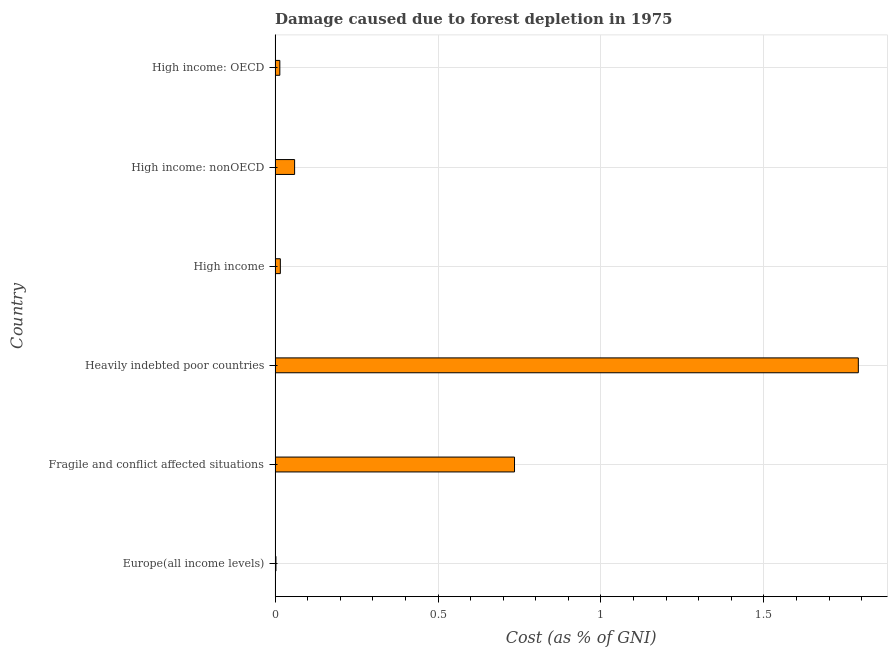Does the graph contain grids?
Provide a succinct answer. Yes. What is the title of the graph?
Offer a very short reply. Damage caused due to forest depletion in 1975. What is the label or title of the X-axis?
Provide a short and direct response. Cost (as % of GNI). What is the damage caused due to forest depletion in High income: nonOECD?
Your answer should be very brief. 0.06. Across all countries, what is the maximum damage caused due to forest depletion?
Keep it short and to the point. 1.79. Across all countries, what is the minimum damage caused due to forest depletion?
Your answer should be very brief. 0. In which country was the damage caused due to forest depletion maximum?
Provide a succinct answer. Heavily indebted poor countries. In which country was the damage caused due to forest depletion minimum?
Provide a short and direct response. Europe(all income levels). What is the sum of the damage caused due to forest depletion?
Give a very brief answer. 2.62. What is the difference between the damage caused due to forest depletion in Heavily indebted poor countries and High income: nonOECD?
Ensure brevity in your answer.  1.73. What is the average damage caused due to forest depletion per country?
Keep it short and to the point. 0.44. What is the median damage caused due to forest depletion?
Your answer should be very brief. 0.04. In how many countries, is the damage caused due to forest depletion greater than 1.1 %?
Provide a succinct answer. 1. What is the ratio of the damage caused due to forest depletion in High income: OECD to that in High income: nonOECD?
Your answer should be compact. 0.24. Is the difference between the damage caused due to forest depletion in Fragile and conflict affected situations and High income greater than the difference between any two countries?
Give a very brief answer. No. What is the difference between the highest and the second highest damage caused due to forest depletion?
Offer a terse response. 1.05. Is the sum of the damage caused due to forest depletion in Fragile and conflict affected situations and High income greater than the maximum damage caused due to forest depletion across all countries?
Your answer should be compact. No. What is the difference between the highest and the lowest damage caused due to forest depletion?
Make the answer very short. 1.79. How many bars are there?
Offer a very short reply. 6. What is the difference between two consecutive major ticks on the X-axis?
Offer a very short reply. 0.5. What is the Cost (as % of GNI) in Europe(all income levels)?
Keep it short and to the point. 0. What is the Cost (as % of GNI) in Fragile and conflict affected situations?
Provide a succinct answer. 0.73. What is the Cost (as % of GNI) of Heavily indebted poor countries?
Provide a succinct answer. 1.79. What is the Cost (as % of GNI) of High income?
Your answer should be very brief. 0.02. What is the Cost (as % of GNI) in High income: nonOECD?
Ensure brevity in your answer.  0.06. What is the Cost (as % of GNI) in High income: OECD?
Keep it short and to the point. 0.01. What is the difference between the Cost (as % of GNI) in Europe(all income levels) and Fragile and conflict affected situations?
Ensure brevity in your answer.  -0.73. What is the difference between the Cost (as % of GNI) in Europe(all income levels) and Heavily indebted poor countries?
Give a very brief answer. -1.79. What is the difference between the Cost (as % of GNI) in Europe(all income levels) and High income?
Make the answer very short. -0.01. What is the difference between the Cost (as % of GNI) in Europe(all income levels) and High income: nonOECD?
Offer a terse response. -0.06. What is the difference between the Cost (as % of GNI) in Europe(all income levels) and High income: OECD?
Offer a very short reply. -0.01. What is the difference between the Cost (as % of GNI) in Fragile and conflict affected situations and Heavily indebted poor countries?
Keep it short and to the point. -1.06. What is the difference between the Cost (as % of GNI) in Fragile and conflict affected situations and High income?
Give a very brief answer. 0.72. What is the difference between the Cost (as % of GNI) in Fragile and conflict affected situations and High income: nonOECD?
Provide a succinct answer. 0.67. What is the difference between the Cost (as % of GNI) in Fragile and conflict affected situations and High income: OECD?
Your response must be concise. 0.72. What is the difference between the Cost (as % of GNI) in Heavily indebted poor countries and High income?
Your response must be concise. 1.77. What is the difference between the Cost (as % of GNI) in Heavily indebted poor countries and High income: nonOECD?
Give a very brief answer. 1.73. What is the difference between the Cost (as % of GNI) in Heavily indebted poor countries and High income: OECD?
Make the answer very short. 1.78. What is the difference between the Cost (as % of GNI) in High income and High income: nonOECD?
Provide a succinct answer. -0.04. What is the difference between the Cost (as % of GNI) in High income and High income: OECD?
Provide a succinct answer. 0. What is the difference between the Cost (as % of GNI) in High income: nonOECD and High income: OECD?
Provide a succinct answer. 0.05. What is the ratio of the Cost (as % of GNI) in Europe(all income levels) to that in Fragile and conflict affected situations?
Keep it short and to the point. 0. What is the ratio of the Cost (as % of GNI) in Europe(all income levels) to that in High income?
Make the answer very short. 0.17. What is the ratio of the Cost (as % of GNI) in Europe(all income levels) to that in High income: nonOECD?
Offer a terse response. 0.04. What is the ratio of the Cost (as % of GNI) in Europe(all income levels) to that in High income: OECD?
Your answer should be compact. 0.18. What is the ratio of the Cost (as % of GNI) in Fragile and conflict affected situations to that in Heavily indebted poor countries?
Make the answer very short. 0.41. What is the ratio of the Cost (as % of GNI) in Fragile and conflict affected situations to that in High income?
Ensure brevity in your answer.  45.54. What is the ratio of the Cost (as % of GNI) in Fragile and conflict affected situations to that in High income: nonOECD?
Offer a terse response. 12.26. What is the ratio of the Cost (as % of GNI) in Fragile and conflict affected situations to that in High income: OECD?
Make the answer very short. 50.41. What is the ratio of the Cost (as % of GNI) in Heavily indebted poor countries to that in High income?
Keep it short and to the point. 110.93. What is the ratio of the Cost (as % of GNI) in Heavily indebted poor countries to that in High income: nonOECD?
Offer a very short reply. 29.86. What is the ratio of the Cost (as % of GNI) in Heavily indebted poor countries to that in High income: OECD?
Offer a very short reply. 122.78. What is the ratio of the Cost (as % of GNI) in High income to that in High income: nonOECD?
Your response must be concise. 0.27. What is the ratio of the Cost (as % of GNI) in High income to that in High income: OECD?
Your answer should be compact. 1.11. What is the ratio of the Cost (as % of GNI) in High income: nonOECD to that in High income: OECD?
Ensure brevity in your answer.  4.11. 